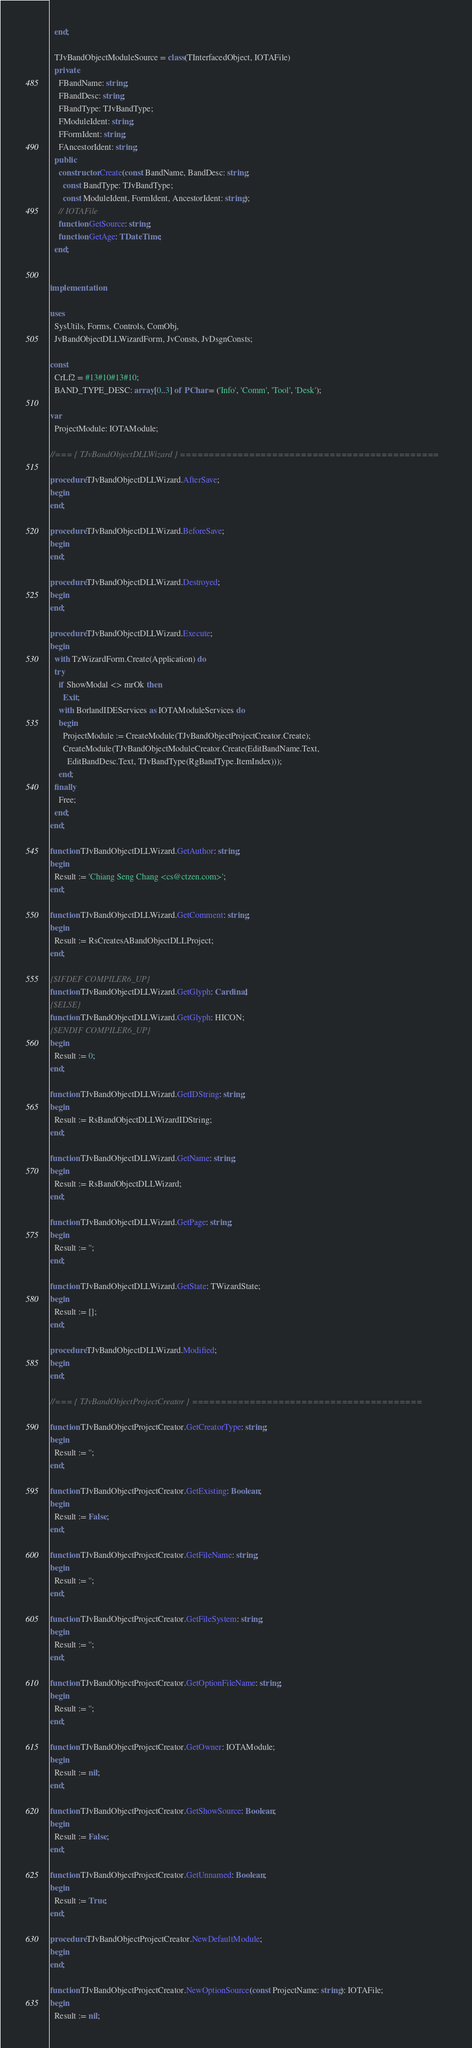<code> <loc_0><loc_0><loc_500><loc_500><_Pascal_>  end;

  TJvBandObjectModuleSource = class(TInterfacedObject, IOTAFile)
  private
    FBandName: string;
    FBandDesc: string;
    FBandType: TJvBandType;
    FModuleIdent: string;
    FFormIdent: string;
    FAncestorIdent: string;
  public
    constructor Create(const BandName, BandDesc: string;
      const BandType: TJvBandType;
      const ModuleIdent, FormIdent, AncestorIdent: string);
    // IOTAFile
    function GetSource: string;
    function GetAge: TDateTime;
  end;


implementation

uses
  SysUtils, Forms, Controls, ComObj,
  JvBandObjectDLLWizardForm, JvConsts, JvDsgnConsts;

const
  CrLf2 = #13#10#13#10;
  BAND_TYPE_DESC: array [0..3] of PChar = ('Info', 'Comm', 'Tool', 'Desk');

var
  ProjectModule: IOTAModule;

//=== { TJvBandObjectDLLWizard } =============================================

procedure TJvBandObjectDLLWizard.AfterSave;
begin
end;

procedure TJvBandObjectDLLWizard.BeforeSave;
begin
end;

procedure TJvBandObjectDLLWizard.Destroyed;
begin
end;

procedure TJvBandObjectDLLWizard.Execute;
begin
  with TzWizardForm.Create(Application) do
  try
    if ShowModal <> mrOk then
      Exit;
    with BorlandIDEServices as IOTAModuleServices do
    begin
      ProjectModule := CreateModule(TJvBandObjectProjectCreator.Create);
      CreateModule(TJvBandObjectModuleCreator.Create(EditBandName.Text,
        EditBandDesc.Text, TJvBandType(RgBandType.ItemIndex)));
    end;
  finally
    Free;
  end;
end;

function TJvBandObjectDLLWizard.GetAuthor: string;
begin
  Result := 'Chiang Seng Chang <cs@ctzen.com>';
end;

function TJvBandObjectDLLWizard.GetComment: string;
begin
  Result := RsCreatesABandObjectDLLProject;
end;

{$IFDEF COMPILER6_UP}
function TJvBandObjectDLLWizard.GetGlyph: Cardinal;
{$ELSE}
function TJvBandObjectDLLWizard.GetGlyph: HICON;
{$ENDIF COMPILER6_UP}
begin
  Result := 0;
end;

function TJvBandObjectDLLWizard.GetIDString: string;
begin
  Result := RsBandObjectDLLWizardIDString;
end;

function TJvBandObjectDLLWizard.GetName: string;
begin
  Result := RsBandObjectDLLWizard;
end;

function TJvBandObjectDLLWizard.GetPage: string;
begin
  Result := '';
end;

function TJvBandObjectDLLWizard.GetState: TWizardState;
begin
  Result := [];
end;

procedure TJvBandObjectDLLWizard.Modified;
begin
end;

//=== { TJvBandObjectProjectCreator } ========================================

function TJvBandObjectProjectCreator.GetCreatorType: string;
begin
  Result := '';
end;

function TJvBandObjectProjectCreator.GetExisting: Boolean;
begin
  Result := False;
end;

function TJvBandObjectProjectCreator.GetFileName: string;
begin
  Result := '';
end;

function TJvBandObjectProjectCreator.GetFileSystem: string;
begin
  Result := '';
end;

function TJvBandObjectProjectCreator.GetOptionFileName: string;
begin
  Result := '';
end;

function TJvBandObjectProjectCreator.GetOwner: IOTAModule;
begin
  Result := nil;
end;

function TJvBandObjectProjectCreator.GetShowSource: Boolean;
begin
  Result := False;
end;

function TJvBandObjectProjectCreator.GetUnnamed: Boolean;
begin
  Result := True;
end;

procedure TJvBandObjectProjectCreator.NewDefaultModule;
begin
end;

function TJvBandObjectProjectCreator.NewOptionSource(const ProjectName: string): IOTAFile;
begin
  Result := nil;</code> 